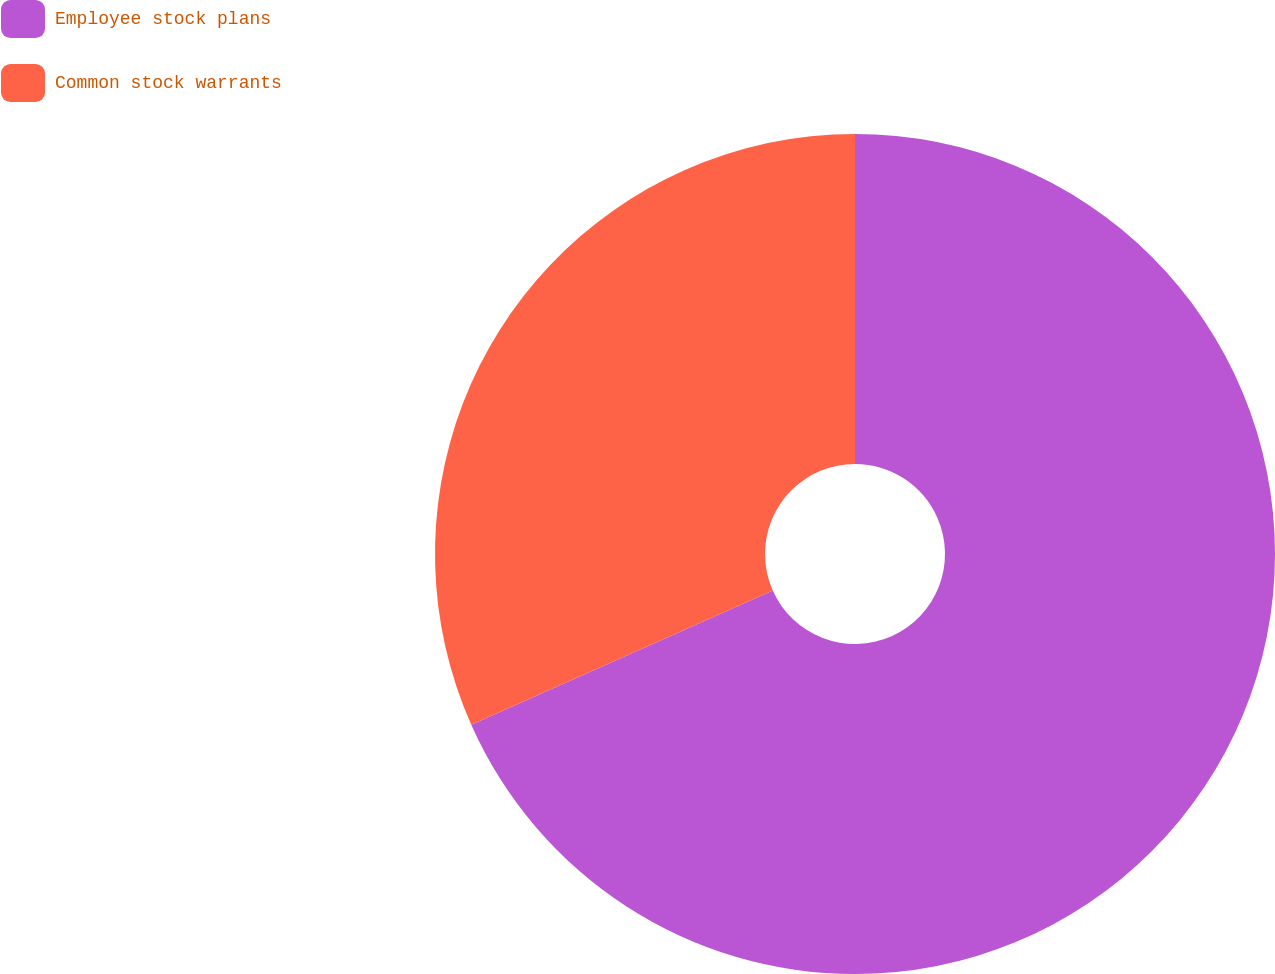Convert chart. <chart><loc_0><loc_0><loc_500><loc_500><pie_chart><fcel>Employee stock plans<fcel>Common stock warrants<nl><fcel>68.34%<fcel>31.66%<nl></chart> 